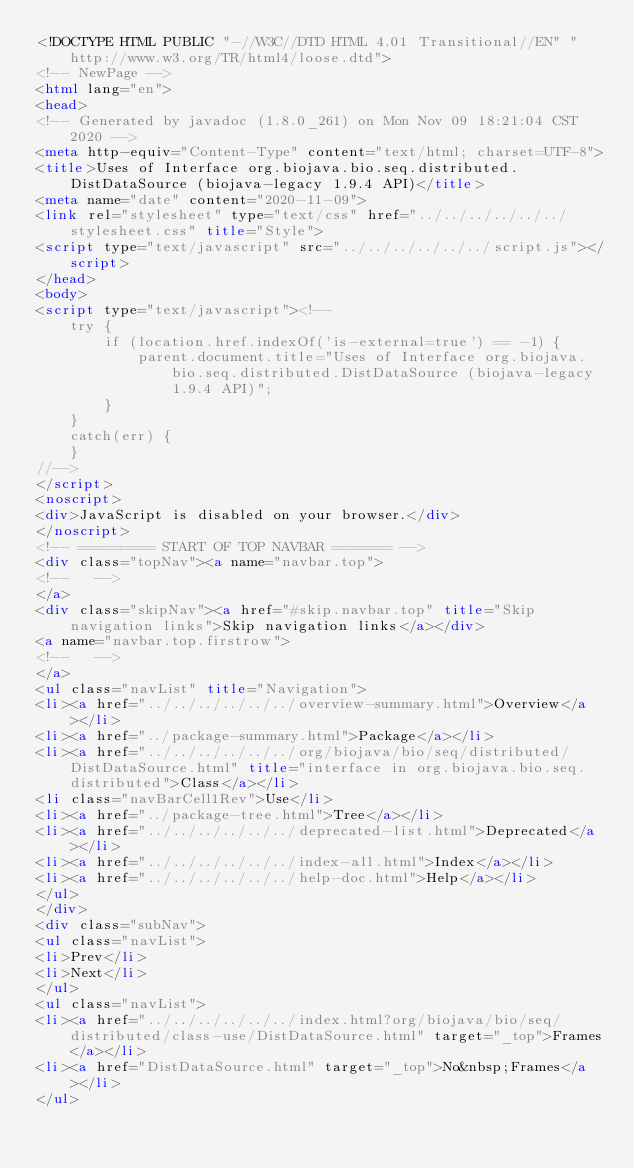Convert code to text. <code><loc_0><loc_0><loc_500><loc_500><_HTML_><!DOCTYPE HTML PUBLIC "-//W3C//DTD HTML 4.01 Transitional//EN" "http://www.w3.org/TR/html4/loose.dtd">
<!-- NewPage -->
<html lang="en">
<head>
<!-- Generated by javadoc (1.8.0_261) on Mon Nov 09 18:21:04 CST 2020 -->
<meta http-equiv="Content-Type" content="text/html; charset=UTF-8">
<title>Uses of Interface org.biojava.bio.seq.distributed.DistDataSource (biojava-legacy 1.9.4 API)</title>
<meta name="date" content="2020-11-09">
<link rel="stylesheet" type="text/css" href="../../../../../../stylesheet.css" title="Style">
<script type="text/javascript" src="../../../../../../script.js"></script>
</head>
<body>
<script type="text/javascript"><!--
    try {
        if (location.href.indexOf('is-external=true') == -1) {
            parent.document.title="Uses of Interface org.biojava.bio.seq.distributed.DistDataSource (biojava-legacy 1.9.4 API)";
        }
    }
    catch(err) {
    }
//-->
</script>
<noscript>
<div>JavaScript is disabled on your browser.</div>
</noscript>
<!-- ========= START OF TOP NAVBAR ======= -->
<div class="topNav"><a name="navbar.top">
<!--   -->
</a>
<div class="skipNav"><a href="#skip.navbar.top" title="Skip navigation links">Skip navigation links</a></div>
<a name="navbar.top.firstrow">
<!--   -->
</a>
<ul class="navList" title="Navigation">
<li><a href="../../../../../../overview-summary.html">Overview</a></li>
<li><a href="../package-summary.html">Package</a></li>
<li><a href="../../../../../../org/biojava/bio/seq/distributed/DistDataSource.html" title="interface in org.biojava.bio.seq.distributed">Class</a></li>
<li class="navBarCell1Rev">Use</li>
<li><a href="../package-tree.html">Tree</a></li>
<li><a href="../../../../../../deprecated-list.html">Deprecated</a></li>
<li><a href="../../../../../../index-all.html">Index</a></li>
<li><a href="../../../../../../help-doc.html">Help</a></li>
</ul>
</div>
<div class="subNav">
<ul class="navList">
<li>Prev</li>
<li>Next</li>
</ul>
<ul class="navList">
<li><a href="../../../../../../index.html?org/biojava/bio/seq/distributed/class-use/DistDataSource.html" target="_top">Frames</a></li>
<li><a href="DistDataSource.html" target="_top">No&nbsp;Frames</a></li>
</ul></code> 